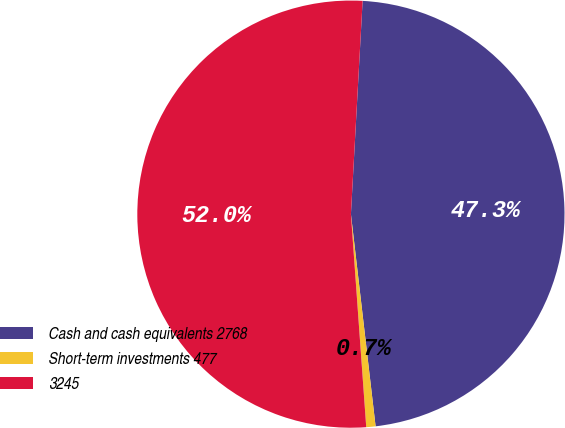Convert chart. <chart><loc_0><loc_0><loc_500><loc_500><pie_chart><fcel>Cash and cash equivalents 2768<fcel>Short­term investments 477<fcel>3245<nl><fcel>47.28%<fcel>0.7%<fcel>52.01%<nl></chart> 